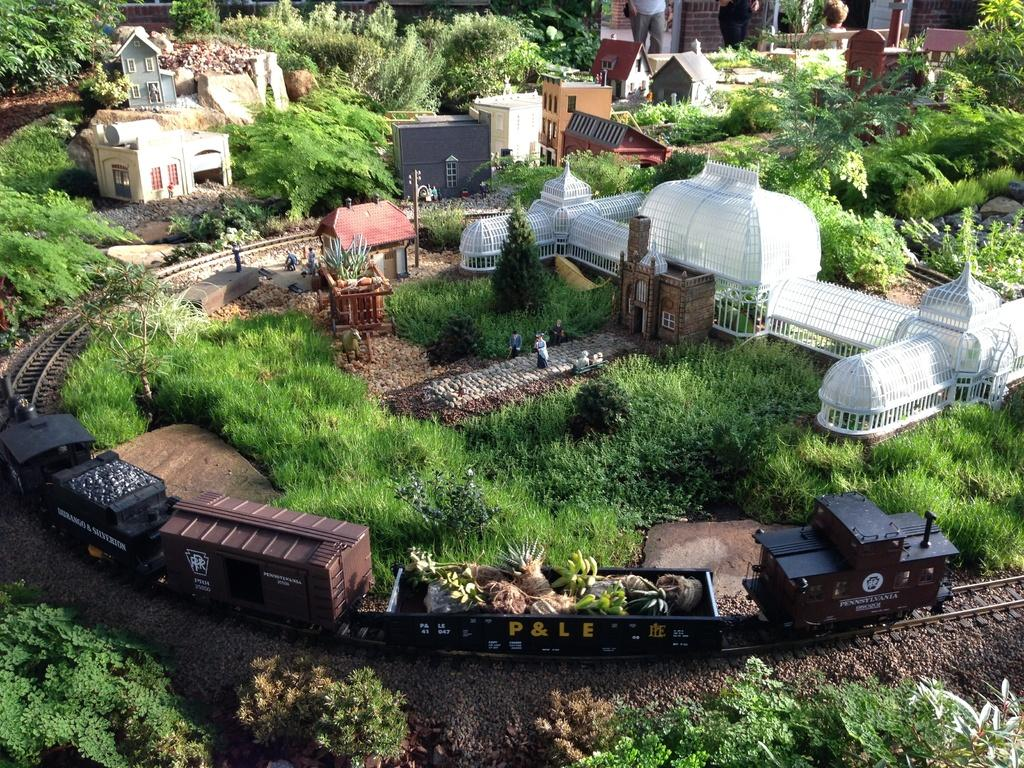What type of living organisms can be seen in the image? Plants are visible in the image. What structure can be seen in the image? There is a pole in the image. What mode of transportation is present in the image? There is a train on a railway track in the image. What type of objects are present in the image? There are objects in the image, such as plants and a pole. What architectural features can be seen in the image? There are buildings with windows in the image. Can you describe the people in the background of the image? There are two people in the background of the image. What type of milk can be seen in the image? There is no milk present in the image. How many girls are visible in the image? There is no mention of girls in the image; only two people are mentioned, but their gender is not specified. 